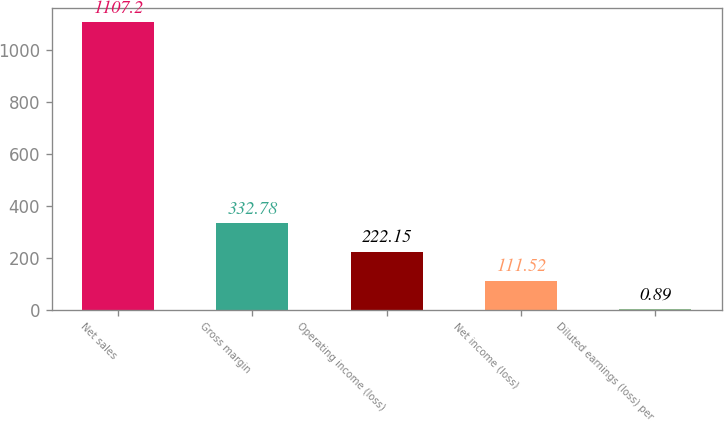<chart> <loc_0><loc_0><loc_500><loc_500><bar_chart><fcel>Net sales<fcel>Gross margin<fcel>Operating income (loss)<fcel>Net income (loss)<fcel>Diluted earnings (loss) per<nl><fcel>1107.2<fcel>332.78<fcel>222.15<fcel>111.52<fcel>0.89<nl></chart> 